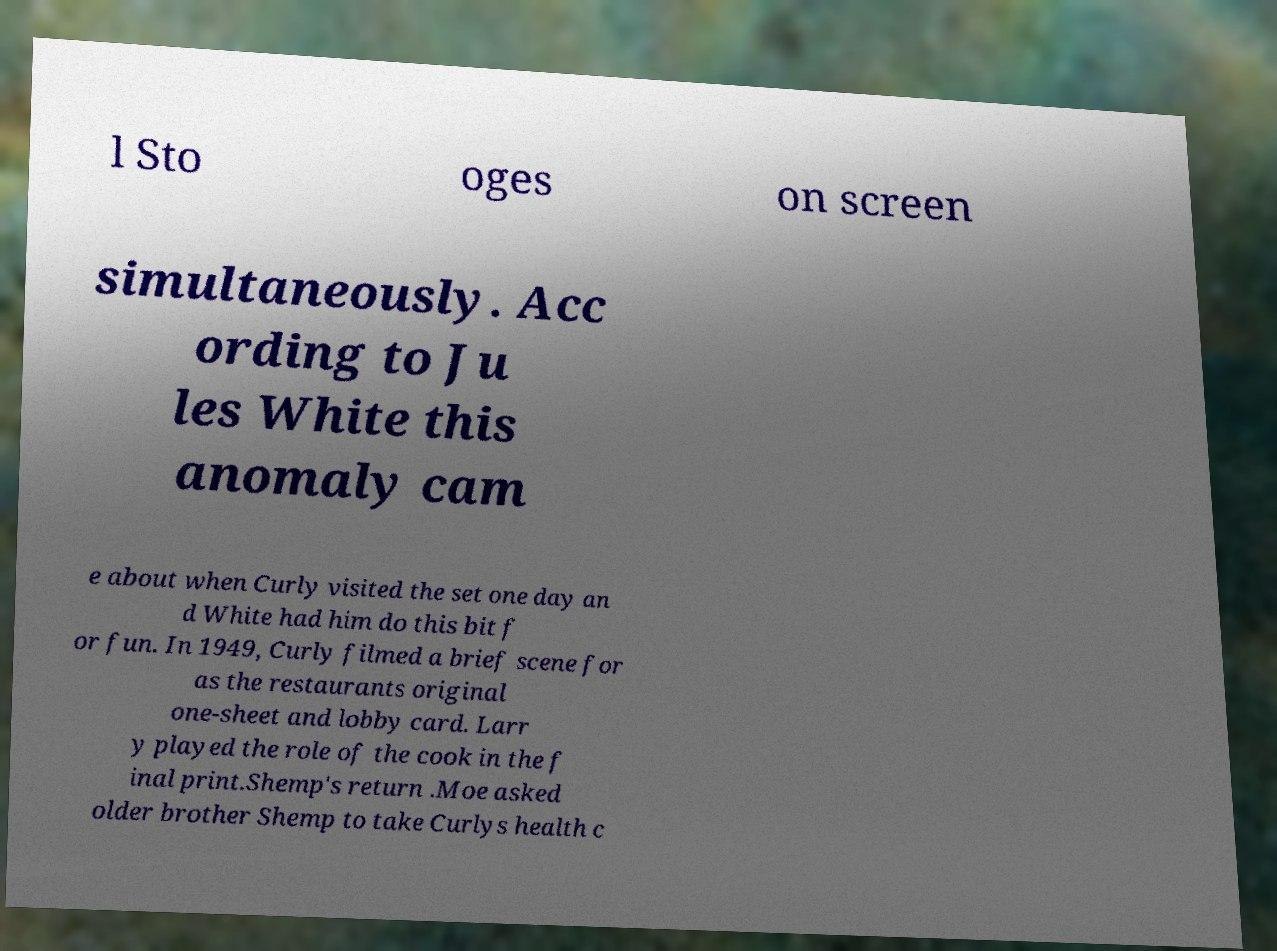Could you extract and type out the text from this image? l Sto oges on screen simultaneously. Acc ording to Ju les White this anomaly cam e about when Curly visited the set one day an d White had him do this bit f or fun. In 1949, Curly filmed a brief scene for as the restaurants original one-sheet and lobby card. Larr y played the role of the cook in the f inal print.Shemp's return .Moe asked older brother Shemp to take Curlys health c 